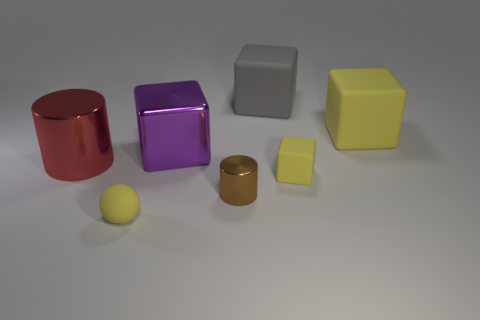How big is the yellow matte object that is behind the big cylinder?
Make the answer very short. Large. How many objects are the same color as the small matte ball?
Ensure brevity in your answer.  2. How many cylinders are blue objects or red objects?
Give a very brief answer. 1. What is the shape of the yellow object that is both left of the big yellow matte cube and right of the large gray matte block?
Offer a terse response. Cube. Are there any gray shiny objects of the same size as the gray cube?
Make the answer very short. No. How many things are either objects to the left of the tiny sphere or large shiny cylinders?
Your answer should be compact. 1. Is the tiny ball made of the same material as the large thing that is on the right side of the small cube?
Your answer should be very brief. Yes. What number of other things are the same shape as the big purple object?
Provide a short and direct response. 3. How many things are large metal things that are on the right side of the red thing or gray matte things behind the purple object?
Provide a succinct answer. 2. What number of other objects are the same color as the large cylinder?
Make the answer very short. 0. 